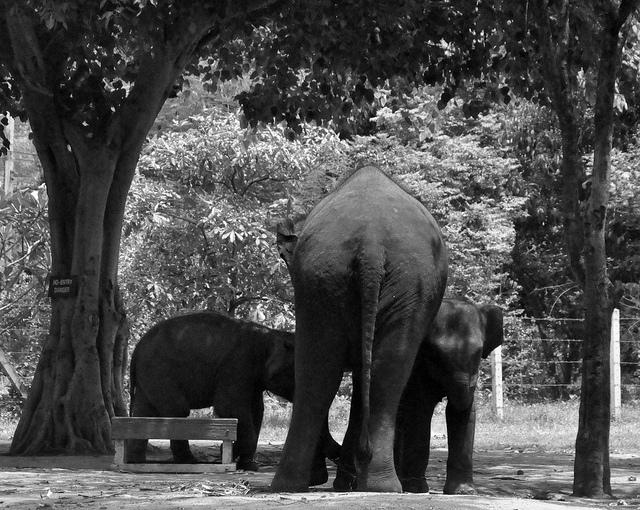What are the Elephants standing on? Please explain your reasoning. concrete. You can tell by all of the tree branches on the ground as to what the elephants are standing on. 